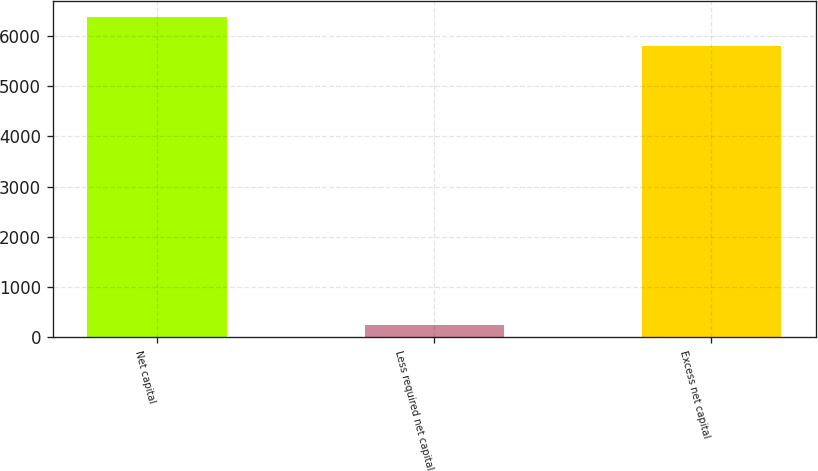Convert chart to OTSL. <chart><loc_0><loc_0><loc_500><loc_500><bar_chart><fcel>Net capital<fcel>Less required net capital<fcel>Excess net capital<nl><fcel>6376.7<fcel>250<fcel>5797<nl></chart> 